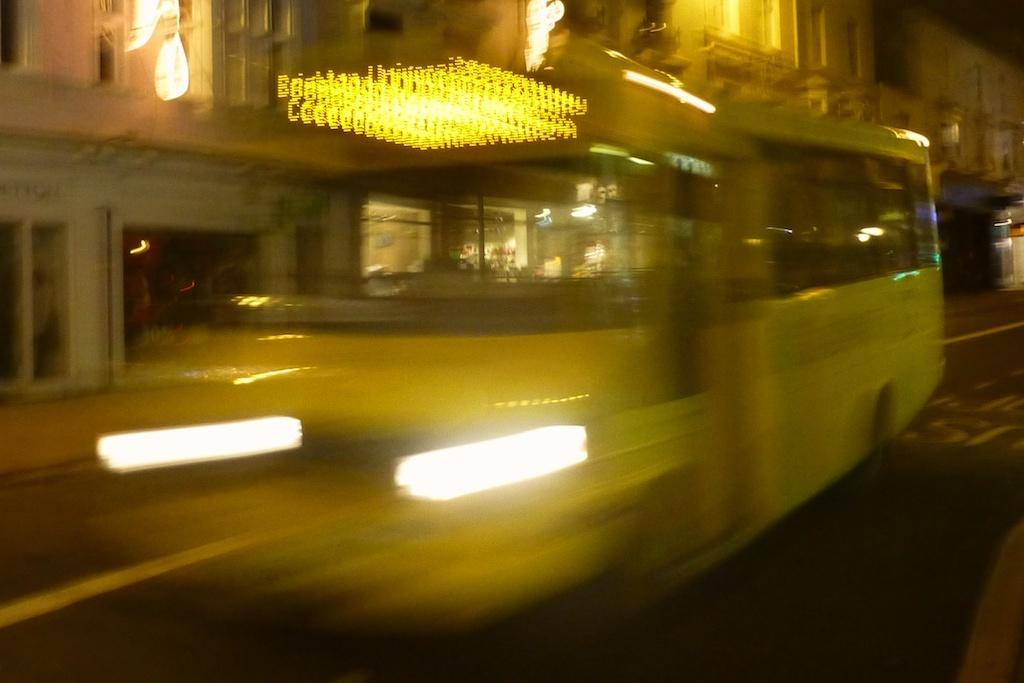What is the main subject of the image? The main subject of the image is a bus. What is the color of the bus? The bus is yellow in color. Are there any shaded areas on the bus? Yes, some parts of the bus are shaded. What can be seen in the background of the image? There are buildings visible behind the bus. What features do the buildings have? The buildings have windows and lights. What type of silver hand can be seen holding the credit card in the image? There is no silver hand or credit card present in the image; it features a yellow bus and buildings in the background. 